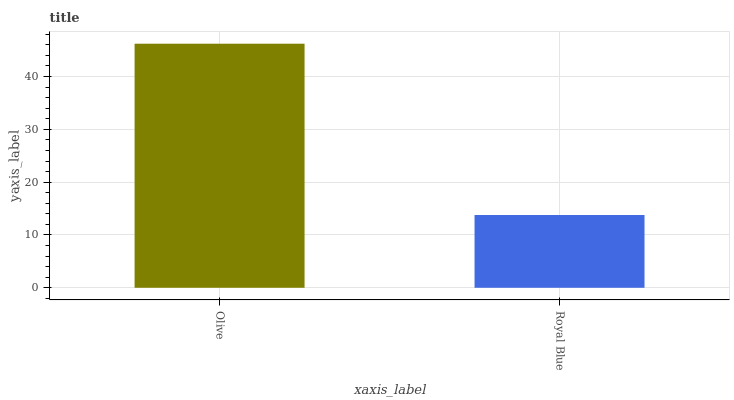Is Royal Blue the maximum?
Answer yes or no. No. Is Olive greater than Royal Blue?
Answer yes or no. Yes. Is Royal Blue less than Olive?
Answer yes or no. Yes. Is Royal Blue greater than Olive?
Answer yes or no. No. Is Olive less than Royal Blue?
Answer yes or no. No. Is Olive the high median?
Answer yes or no. Yes. Is Royal Blue the low median?
Answer yes or no. Yes. Is Royal Blue the high median?
Answer yes or no. No. Is Olive the low median?
Answer yes or no. No. 